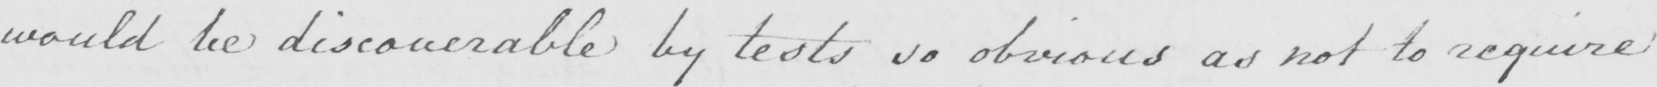What does this handwritten line say? would be discoverable by tests so obvious as not to require 